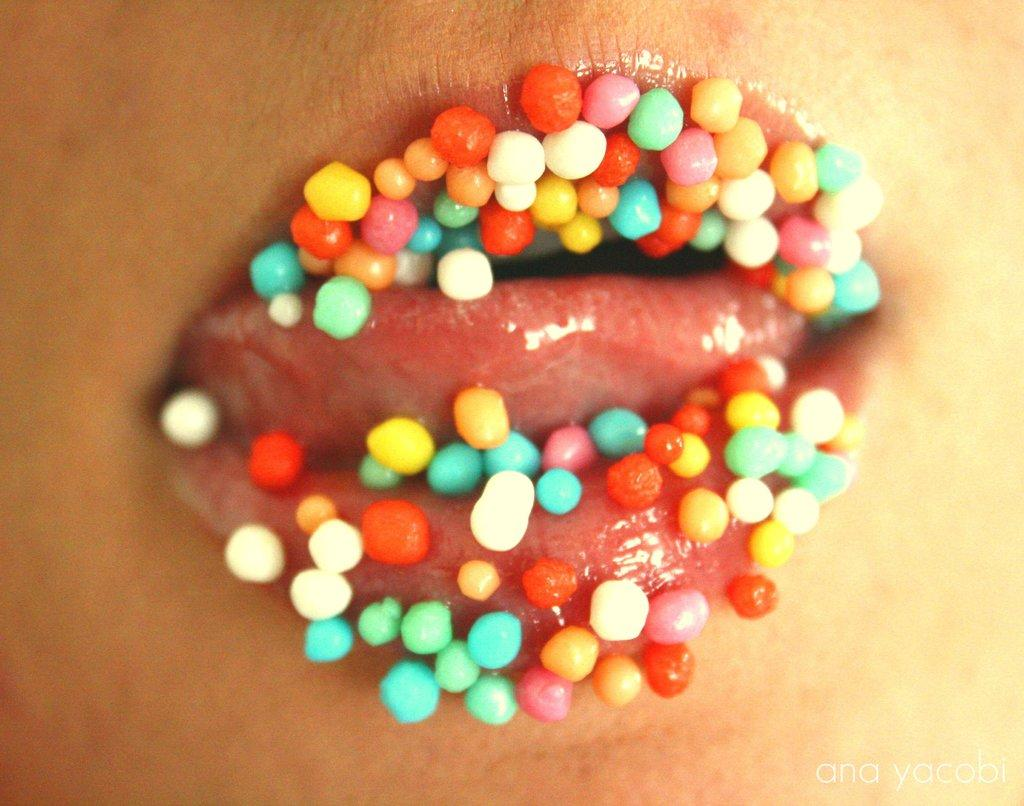What is the main focus of the image? The image contains a close view of a person's lips. Are there any other objects or elements visible in the image? Yes, there are colorful thermocol balls in the image. What type of vegetable is being used as a scarf in the image? There is no vegetable or scarf present in the image. 